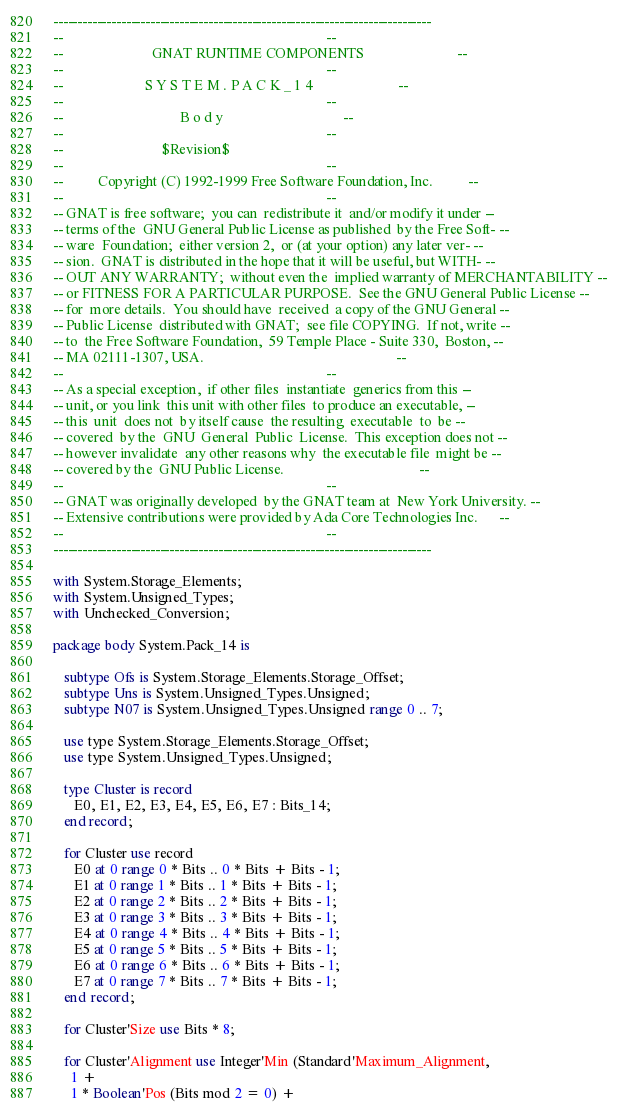<code> <loc_0><loc_0><loc_500><loc_500><_Ada_>------------------------------------------------------------------------------
--                                                                          --
--                         GNAT RUNTIME COMPONENTS                          --
--                                                                          --
--                       S Y S T E M . P A C K _ 1 4                        --
--                                                                          --
--                                 B o d y                                  --
--                                                                          --
--                            $Revision$
--                                                                          --
--          Copyright (C) 1992-1999 Free Software Foundation, Inc.          --
--                                                                          --
-- GNAT is free software;  you can  redistribute it  and/or modify it under --
-- terms of the  GNU General Public License as published  by the Free Soft- --
-- ware  Foundation;  either version 2,  or (at your option) any later ver- --
-- sion.  GNAT is distributed in the hope that it will be useful, but WITH- --
-- OUT ANY WARRANTY;  without even the  implied warranty of MERCHANTABILITY --
-- or FITNESS FOR A PARTICULAR PURPOSE.  See the GNU General Public License --
-- for  more details.  You should have  received  a copy of the GNU General --
-- Public License  distributed with GNAT;  see file COPYING.  If not, write --
-- to  the Free Software Foundation,  59 Temple Place - Suite 330,  Boston, --
-- MA 02111-1307, USA.                                                      --
--                                                                          --
-- As a special exception,  if other files  instantiate  generics from this --
-- unit, or you link  this unit with other files  to produce an executable, --
-- this  unit  does not  by itself cause  the resulting  executable  to  be --
-- covered  by the  GNU  General  Public  License.  This exception does not --
-- however invalidate  any other reasons why  the executable file  might be --
-- covered by the  GNU Public License.                                      --
--                                                                          --
-- GNAT was originally developed  by the GNAT team at  New York University. --
-- Extensive contributions were provided by Ada Core Technologies Inc.      --
--                                                                          --
------------------------------------------------------------------------------

with System.Storage_Elements;
with System.Unsigned_Types;
with Unchecked_Conversion;

package body System.Pack_14 is

   subtype Ofs is System.Storage_Elements.Storage_Offset;
   subtype Uns is System.Unsigned_Types.Unsigned;
   subtype N07 is System.Unsigned_Types.Unsigned range 0 .. 7;

   use type System.Storage_Elements.Storage_Offset;
   use type System.Unsigned_Types.Unsigned;

   type Cluster is record
      E0, E1, E2, E3, E4, E5, E6, E7 : Bits_14;
   end record;

   for Cluster use record
      E0 at 0 range 0 * Bits .. 0 * Bits + Bits - 1;
      E1 at 0 range 1 * Bits .. 1 * Bits + Bits - 1;
      E2 at 0 range 2 * Bits .. 2 * Bits + Bits - 1;
      E3 at 0 range 3 * Bits .. 3 * Bits + Bits - 1;
      E4 at 0 range 4 * Bits .. 4 * Bits + Bits - 1;
      E5 at 0 range 5 * Bits .. 5 * Bits + Bits - 1;
      E6 at 0 range 6 * Bits .. 6 * Bits + Bits - 1;
      E7 at 0 range 7 * Bits .. 7 * Bits + Bits - 1;
   end record;

   for Cluster'Size use Bits * 8;

   for Cluster'Alignment use Integer'Min (Standard'Maximum_Alignment,
     1 +
     1 * Boolean'Pos (Bits mod 2 = 0) +</code> 